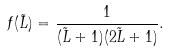<formula> <loc_0><loc_0><loc_500><loc_500>f ( \tilde { L } ) = \frac { 1 } { ( \tilde { L } + 1 ) ( 2 \tilde { L } + 1 ) } .</formula> 